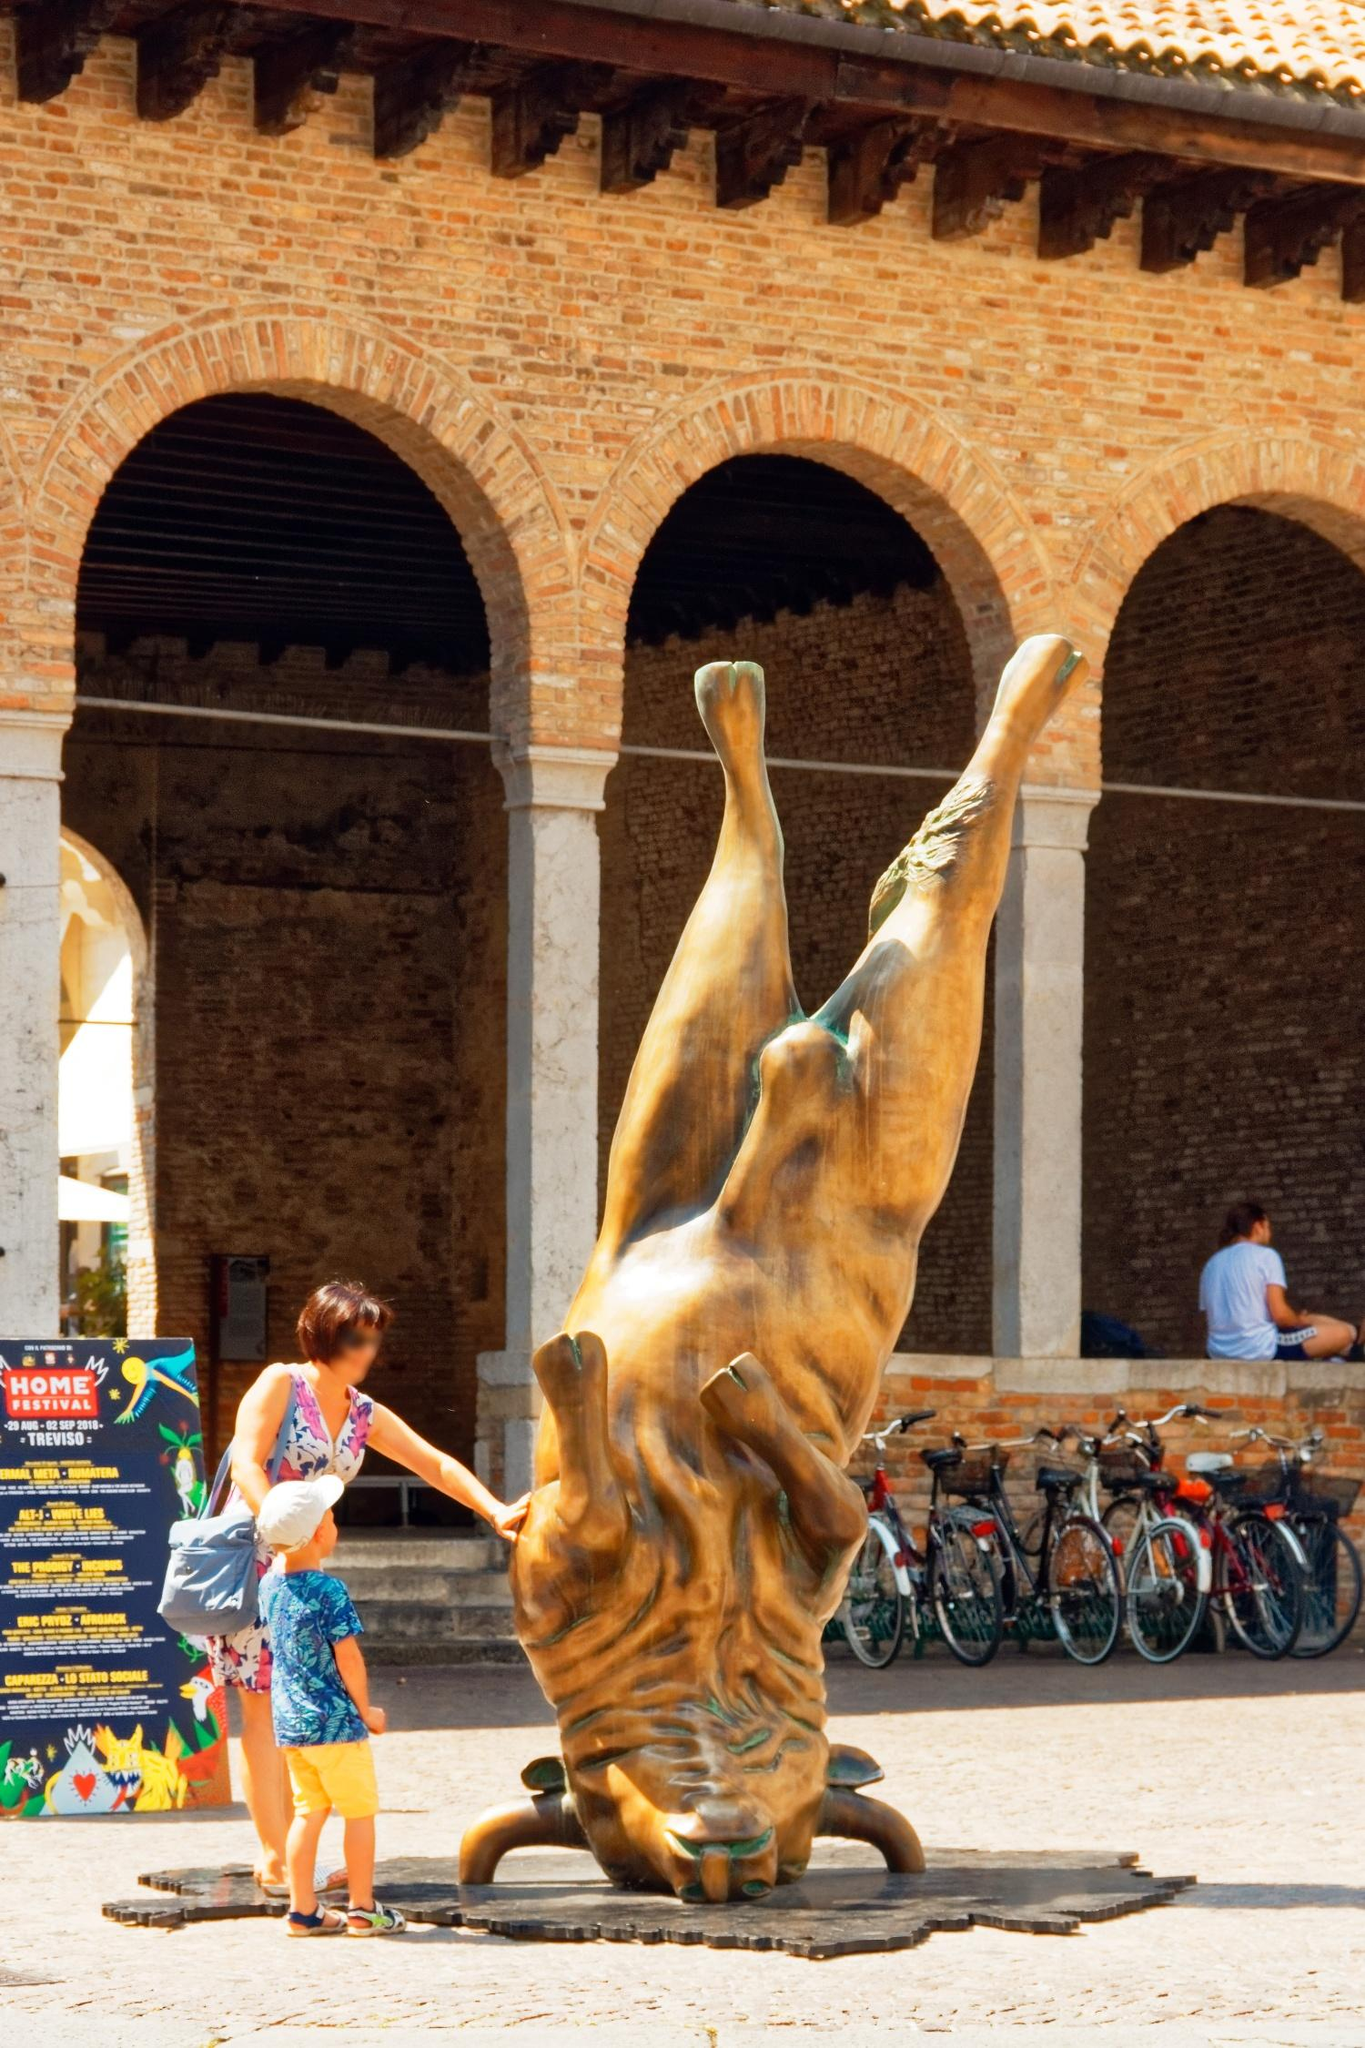Imagine if the bronze sculpture could speak. What stories might it tell? If the bronze bull sculpture could speak, it might regale us with stories of its creation and installation in this ancient courtyard. It could share the artist's vision behind its upside-down placement, perhaps hinting at themes of inversion, challenge, or a reflection on societal norms. The sculpture might describe the countless hands that have touched its surface, from curious children to contemplative adults, each leaving a silent, invisible mark of interaction.

With a view of the courtyard's daily life, the bull would recount the myriad scenes it has witnessed: lovers sharing a tender moment, artists sketching its form, tourists taking photographs, and festivals breathing life into the space. It could speak of the changing seasons, the weathered bricks of the arches, and the stories they silently hold.

The sculpture might also tell tales of the city's bustling spirit, the harmony of historical and modern elements coexisting, and how it stands as a guardian and observer of this intersection of time and cultures. Through the bronze bull's tales, one could gain a deeper appreciation of both the artwork and the vibrant life it oversees in the Castello Sforzesco courtyard. 